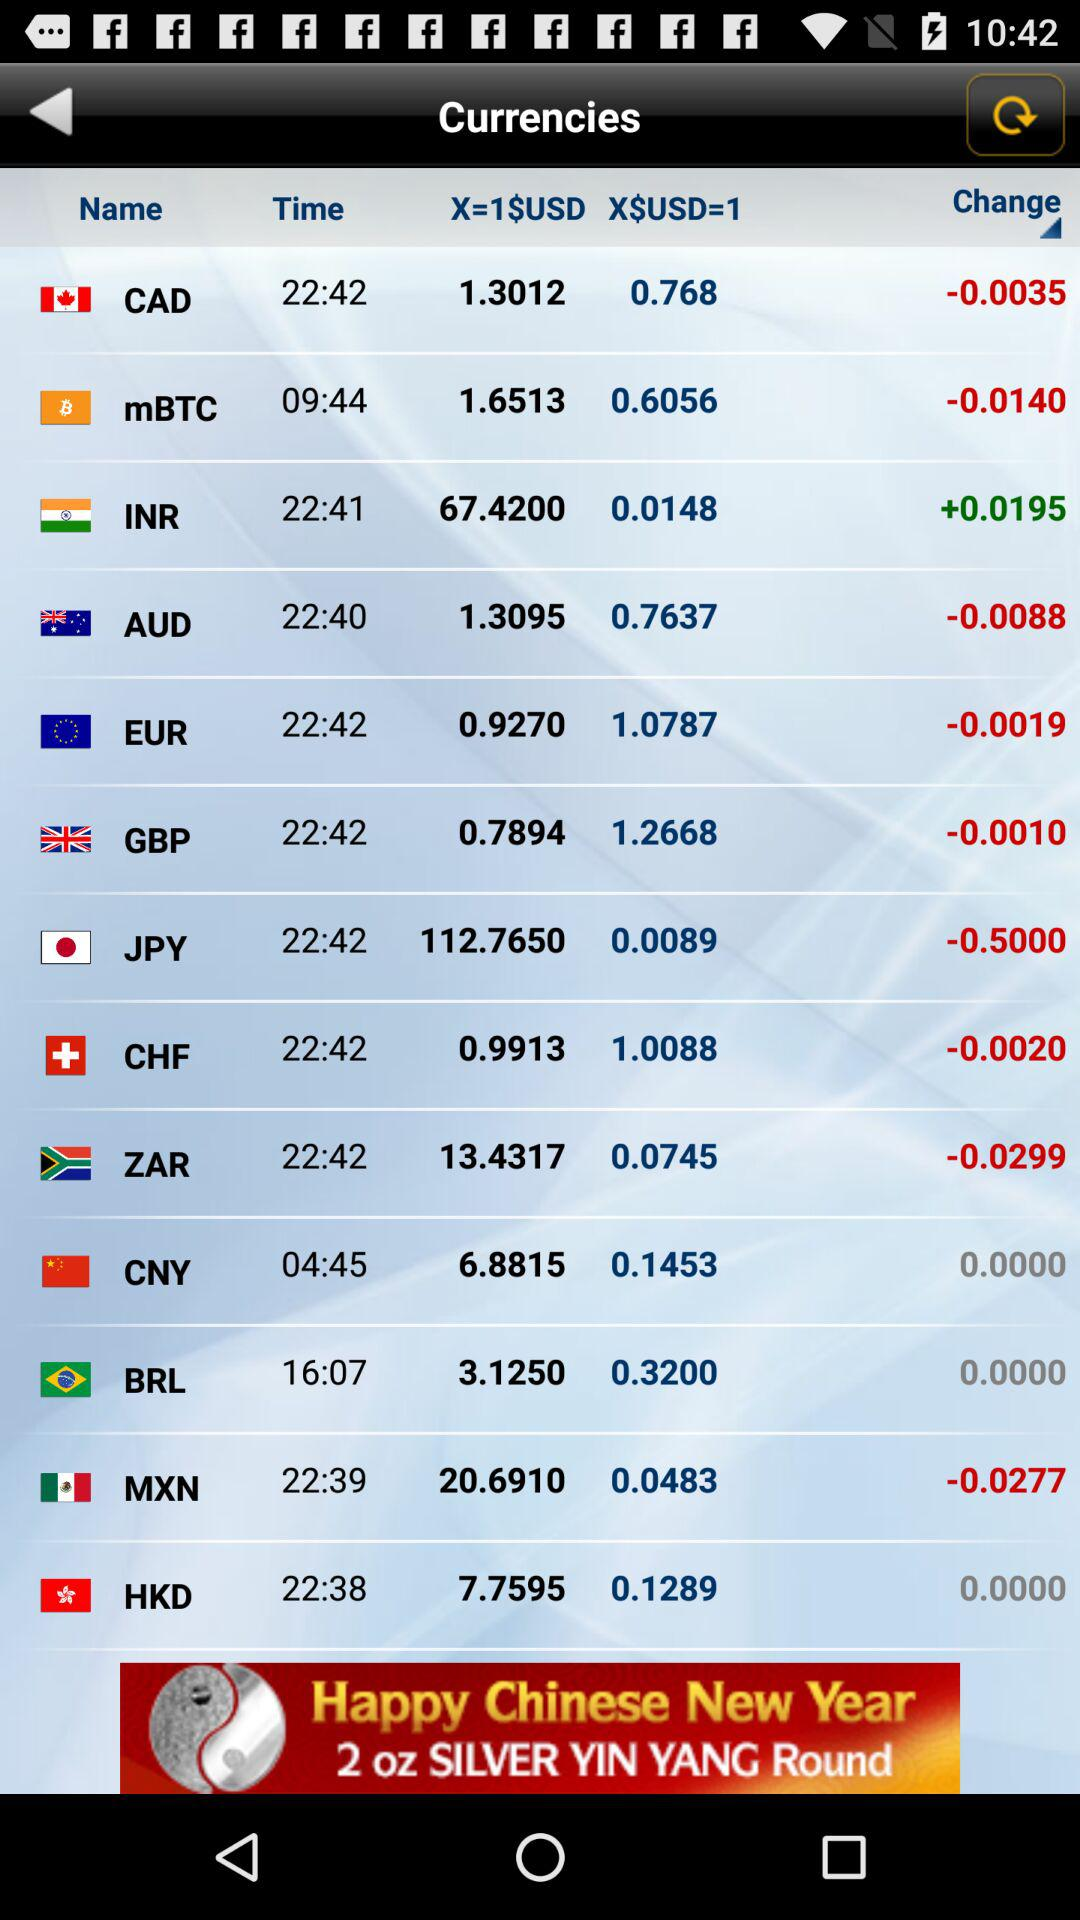How much USD has changed in INR? The change in USD is +0.0195. 